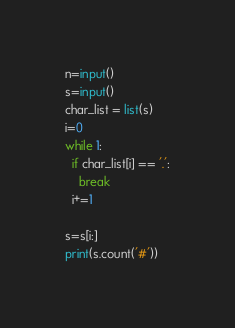<code> <loc_0><loc_0><loc_500><loc_500><_Python_>n=input()
s=input()
char_list = list(s)
i=0
while 1:
  if char_list[i] == '.':
    break
  i+=1

s=s[i:]
print(s.count('#'))</code> 